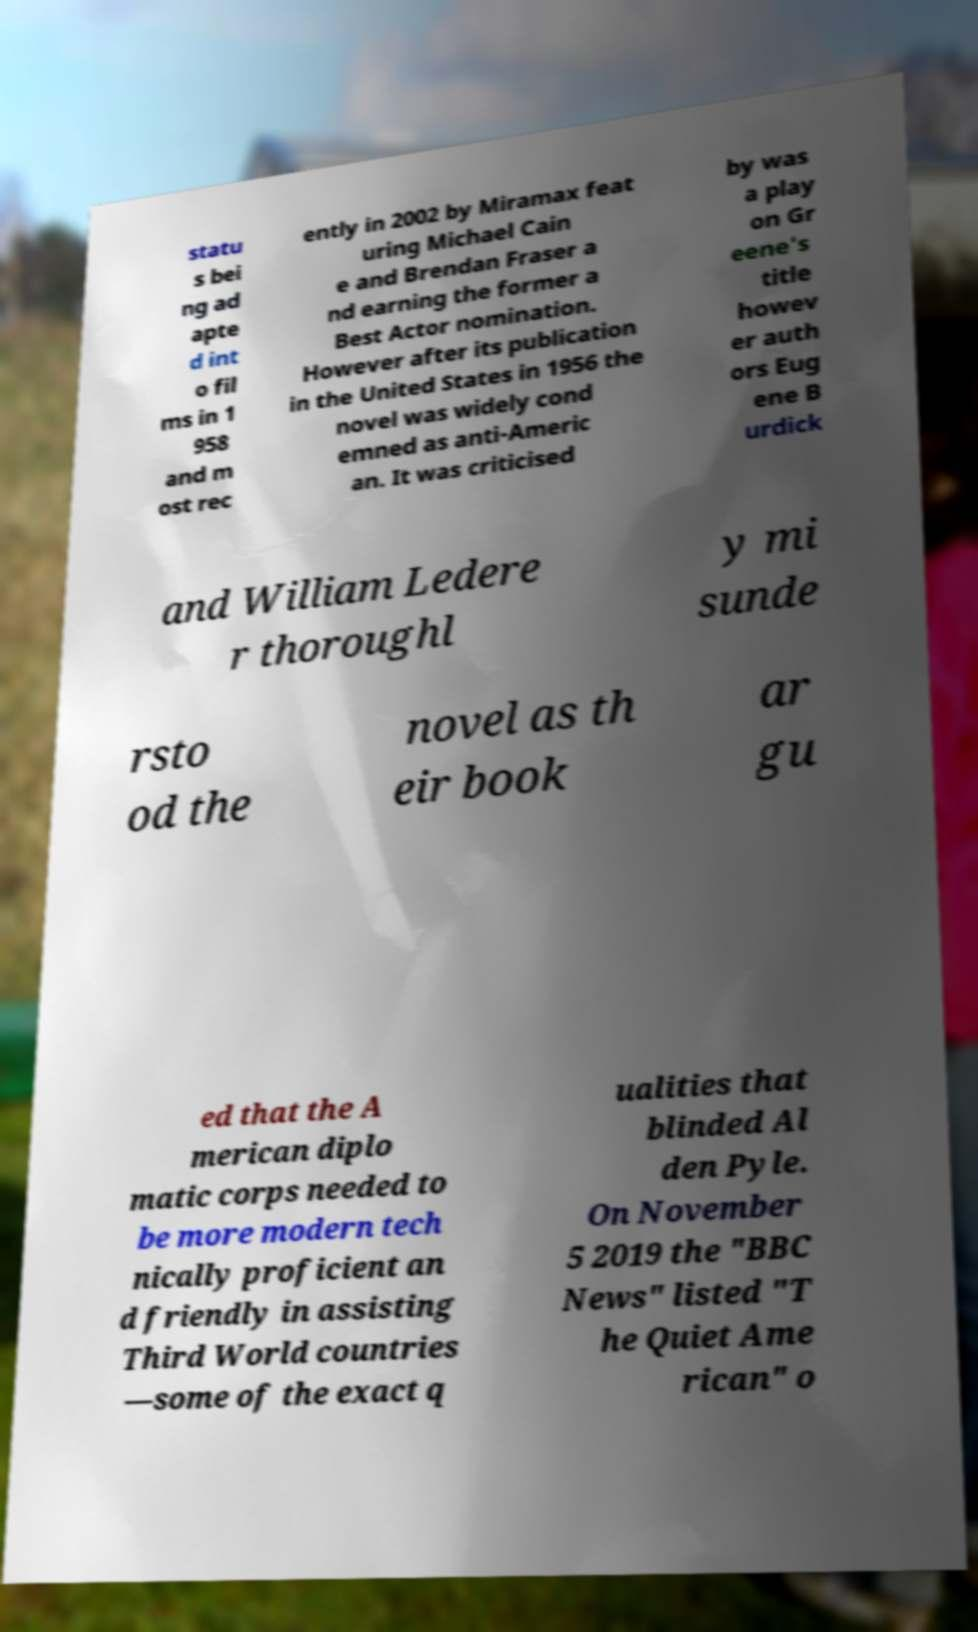Can you accurately transcribe the text from the provided image for me? statu s bei ng ad apte d int o fil ms in 1 958 and m ost rec ently in 2002 by Miramax feat uring Michael Cain e and Brendan Fraser a nd earning the former a Best Actor nomination. However after its publication in the United States in 1956 the novel was widely cond emned as anti-Americ an. It was criticised by was a play on Gr eene's title howev er auth ors Eug ene B urdick and William Ledere r thoroughl y mi sunde rsto od the novel as th eir book ar gu ed that the A merican diplo matic corps needed to be more modern tech nically proficient an d friendly in assisting Third World countries —some of the exact q ualities that blinded Al den Pyle. On November 5 2019 the "BBC News" listed "T he Quiet Ame rican" o 